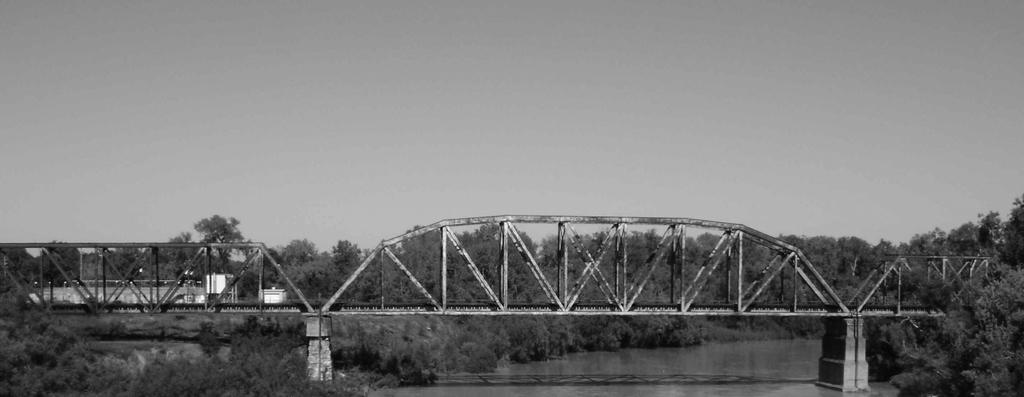What type of structure can be seen in the image? There is a bridge in the image. What type of vegetation is present in the image? There are trees in the image. What type of material is used for the rods in the image? Metal rods are present in the image. What type of man-made structures can be seen in the image? There are buildings in the image. What type of vertical structures are visible in the image? Poles are are are visible in the image. What type of illumination is present in the image? Lights are present in the image. What type of natural element is visible in the image? Water is visible in the image. What can be seen in the background of the image? The sky is visible in the background of the image. Where is the cake located in the image? There is no cake present in the image. What type of creature is shown interacting with the bridge in the image? There is no creature shown interacting with the bridge in the image; only the bridge, trees, metal rods, buildings, poles, lights, water, and sky are present. 